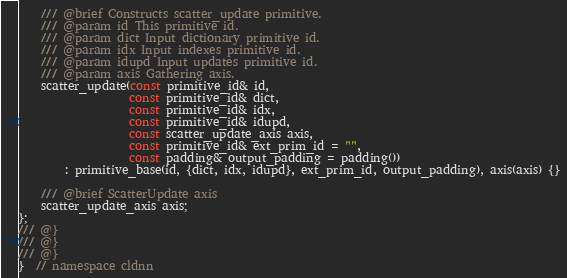<code> <loc_0><loc_0><loc_500><loc_500><_C++_>
    /// @brief Constructs scatter_update primitive.
    /// @param id This primitive id.
    /// @param dict Input dictionary primitive id.
    /// @param idx Input indexes primitive id.
    /// @param idupd Input updates primitive id.
    /// @param axis Gathering axis.
    scatter_update(const primitive_id& id,
                   const primitive_id& dict,
                   const primitive_id& idx,
                   const primitive_id& idupd,
                   const scatter_update_axis axis,
                   const primitive_id& ext_prim_id = "",
                   const padding& output_padding = padding())
        : primitive_base(id, {dict, idx, idupd}, ext_prim_id, output_padding), axis(axis) {}

    /// @brief ScatterUpdate axis
    scatter_update_axis axis;
};
/// @}
/// @}
/// @}
}  // namespace cldnn
</code> 